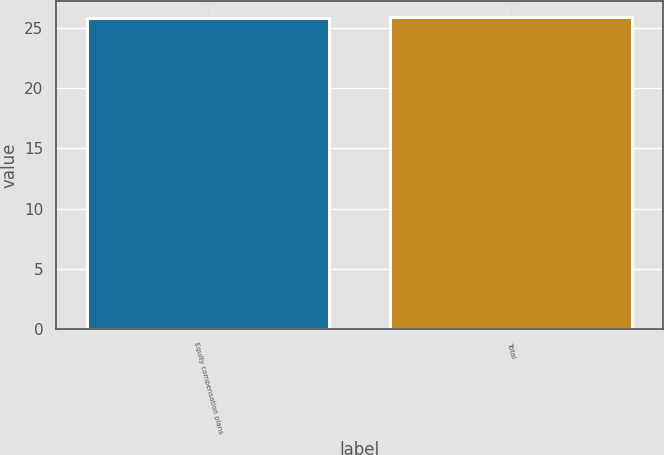Convert chart to OTSL. <chart><loc_0><loc_0><loc_500><loc_500><bar_chart><fcel>Equity compensation plans<fcel>Total<nl><fcel>25.84<fcel>25.94<nl></chart> 